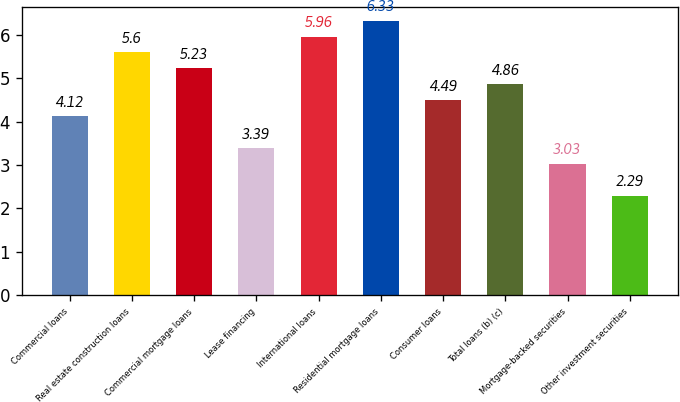Convert chart to OTSL. <chart><loc_0><loc_0><loc_500><loc_500><bar_chart><fcel>Commercial loans<fcel>Real estate construction loans<fcel>Commercial mortgage loans<fcel>Lease financing<fcel>International loans<fcel>Residential mortgage loans<fcel>Consumer loans<fcel>Total loans (b) (c)<fcel>Mortgage-backed securities<fcel>Other investment securities<nl><fcel>4.12<fcel>5.6<fcel>5.23<fcel>3.39<fcel>5.96<fcel>6.33<fcel>4.49<fcel>4.86<fcel>3.03<fcel>2.29<nl></chart> 